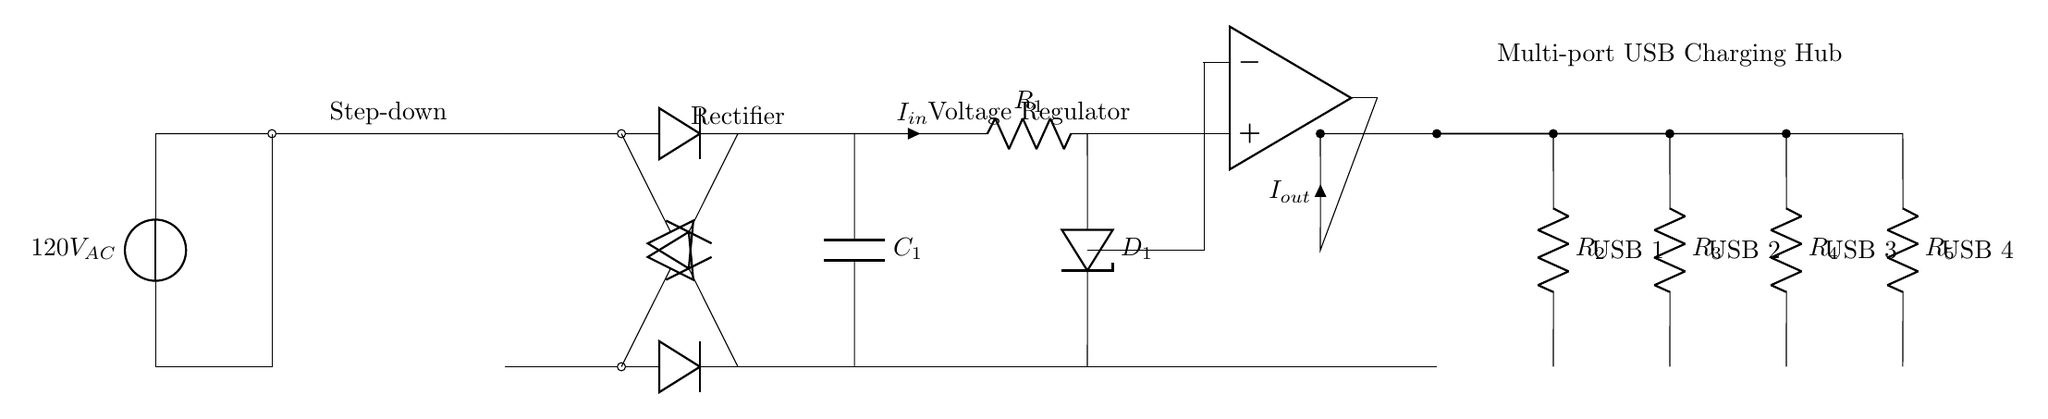What is the input voltage for this circuit? The input voltage is indicated as 120V AC, which is shown at the beginning of the circuit where the voltage source is placed.
Answer: 120V AC What type of component is used to convert AC to DC? The circuit utilizes a diode for this purpose, indicated by the placement of diodes in the rectifier section where the AC is converted to DC.
Answer: Diode How many USB ports are present in this circuit? There are four separate paths leading to USB ports, each with its own resistor indicating four distinct USB output connections.
Answer: 4 What is the function of the transformer in this circuit? The transformer is used to step down the voltage from 120V AC to a lower AC voltage, which is essential for safe charging of devices.
Answer: Step down What is the role of the voltage regulator in the circuit? The voltage regulator stabilizes and regulates the output voltage to ensure that it remains at a safe and consistent level for charging the batteries.
Answer: Stabilizes voltage How are the USB ports connected to the main circuit? The USB ports are connected in parallel to the output of the voltage regulator, ensuring that each port can draw current independently from the power source.
Answer: In parallel What type of circuit is depicted here? This circuit is a charging circuit designed specifically for charging multiple devices simultaneously, indicated by the multi-port USB charging hub label.
Answer: Charging circuit 